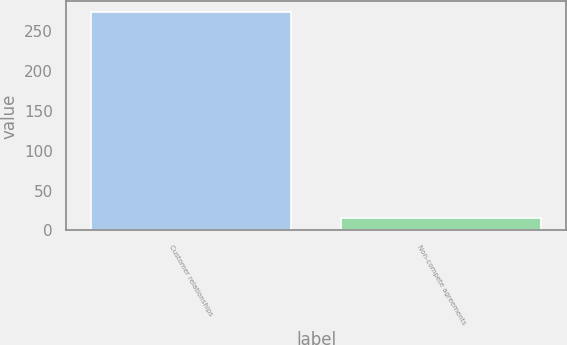Convert chart to OTSL. <chart><loc_0><loc_0><loc_500><loc_500><bar_chart><fcel>Customer relationships<fcel>Non-compete agreements<nl><fcel>274<fcel>15<nl></chart> 